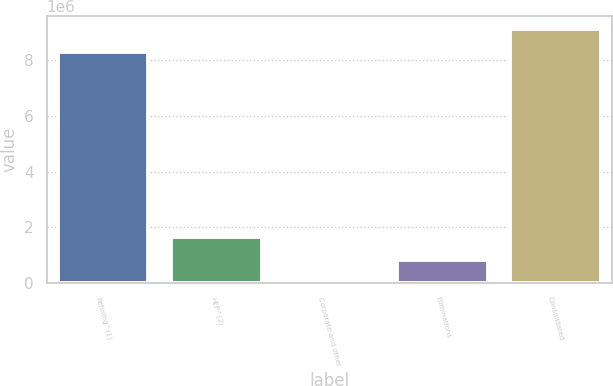Convert chart to OTSL. <chart><loc_0><loc_0><loc_500><loc_500><bar_chart><fcel>Refining^(1)<fcel>HEP^(2)<fcel>Corporate and other<fcel>Eliminations<fcel>Consolidated<nl><fcel>8.287e+06<fcel>1.66492e+06<fcel>415<fcel>832666<fcel>9.11925e+06<nl></chart> 